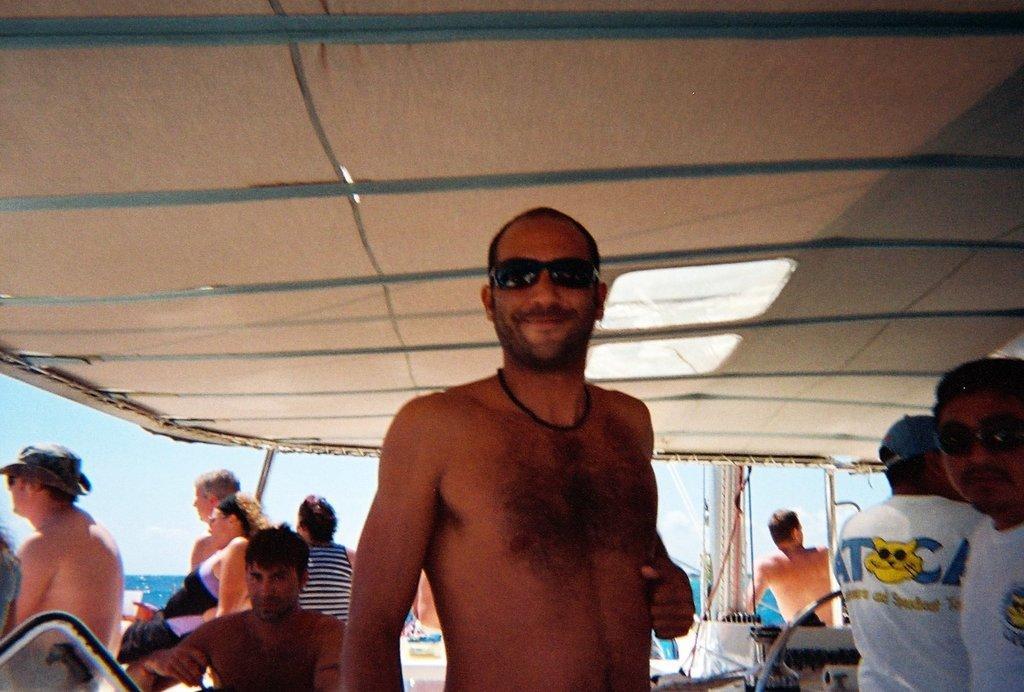Could you give a brief overview of what you see in this image? In this image we can see some people standing under a roof. On the backside we can see a large water body, poles and the sky which looks cloudy. 